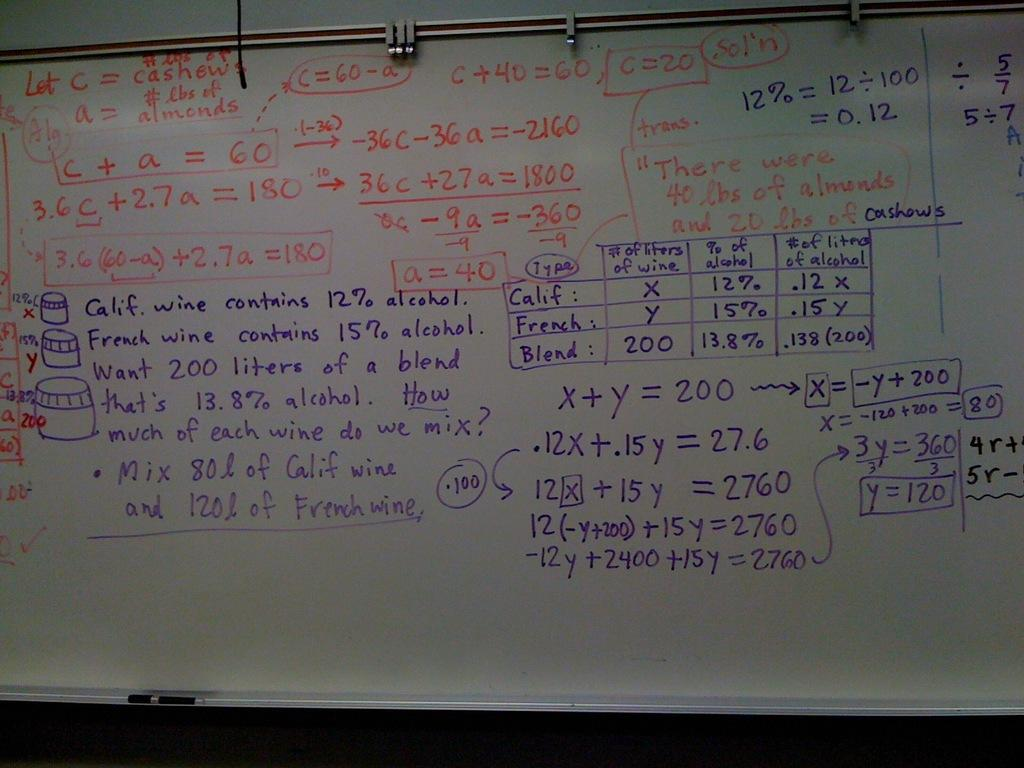<image>
Render a clear and concise summary of the photo. Notes on a whiteboard include a question about wines from California and France. 